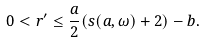Convert formula to latex. <formula><loc_0><loc_0><loc_500><loc_500>0 < r ^ { \prime } \leq \frac { a } { 2 } ( s ( a , \omega ) + 2 ) - b .</formula> 